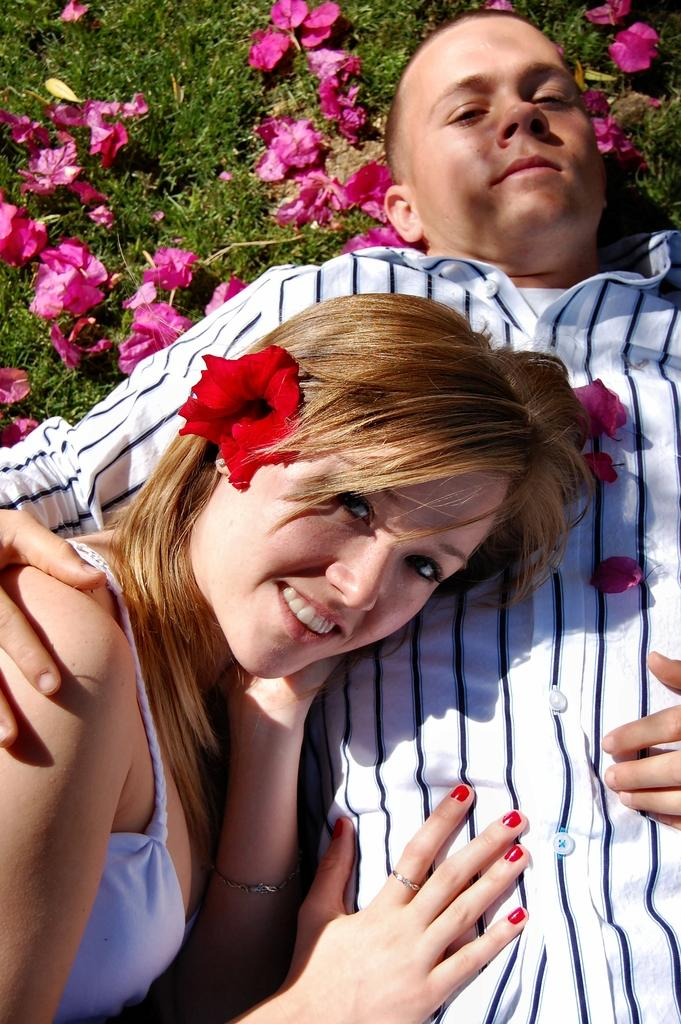How many people are in the image? There are two people in the image. What expression do the people have in the image? The people are smiling in the image. What can be seen in the background of the image? There are flowers on the grass in the background of the image. What type of fall can be seen in the image? There is no fall present in the image. What type of approval is being given in the image? There is no approval being given in the image; it simply shows two people smiling. What type of ants can be seen in the image? There are no ants present in the image. 